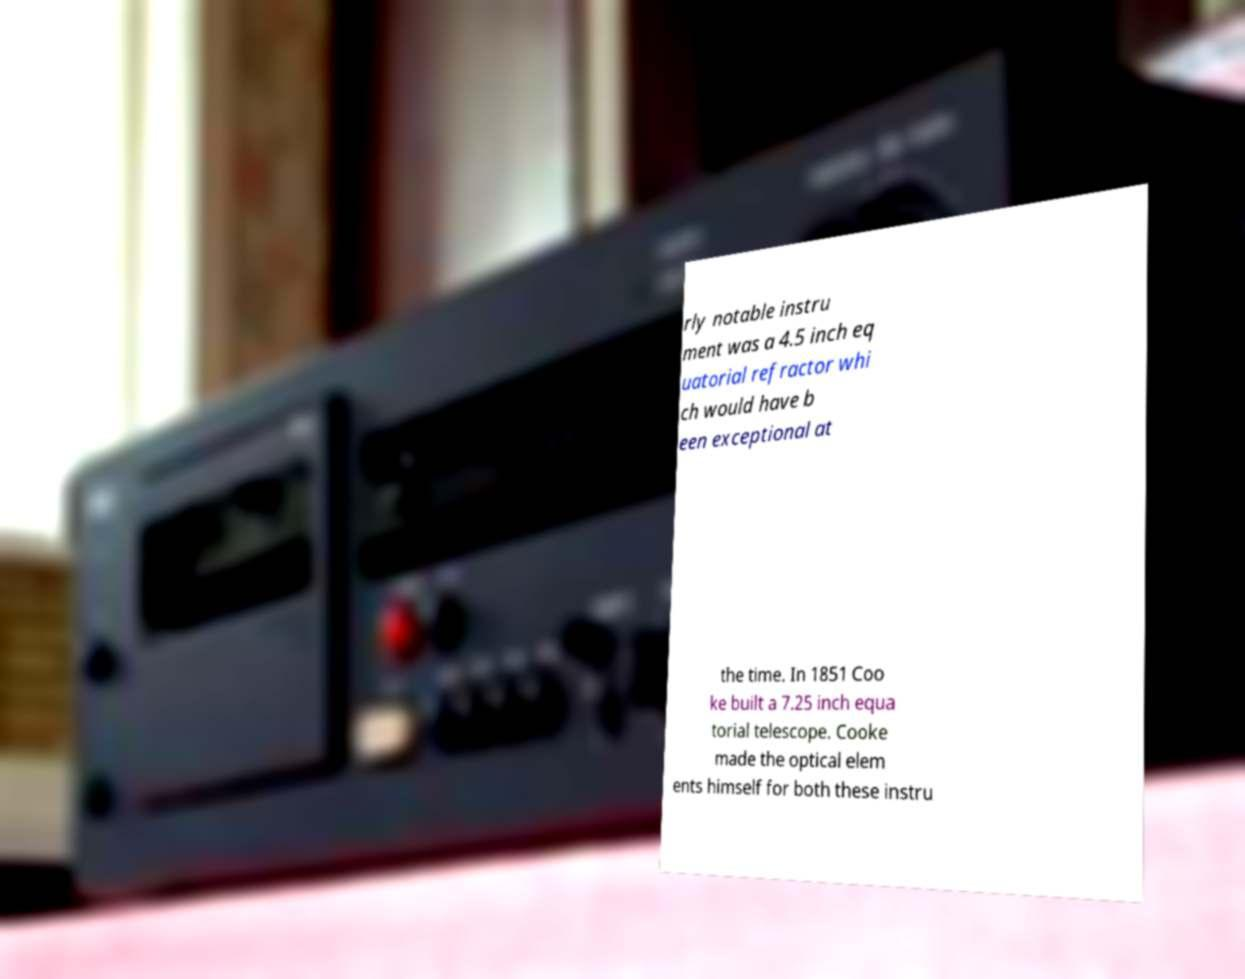Please read and relay the text visible in this image. What does it say? rly notable instru ment was a 4.5 inch eq uatorial refractor whi ch would have b een exceptional at the time. In 1851 Coo ke built a 7.25 inch equa torial telescope. Cooke made the optical elem ents himself for both these instru 